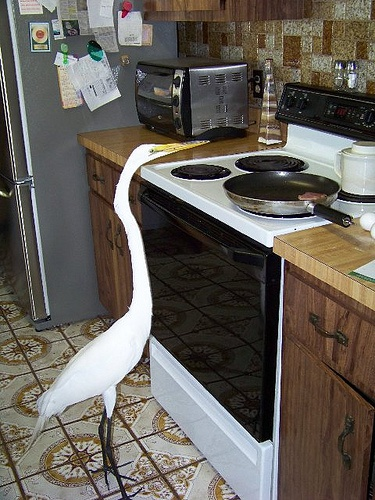Describe the objects in this image and their specific colors. I can see refrigerator in black, gray, darkgray, and lightgray tones, oven in black, darkgray, and lightgray tones, bird in black, white, darkgray, and gray tones, and microwave in black, gray, and darkgray tones in this image. 